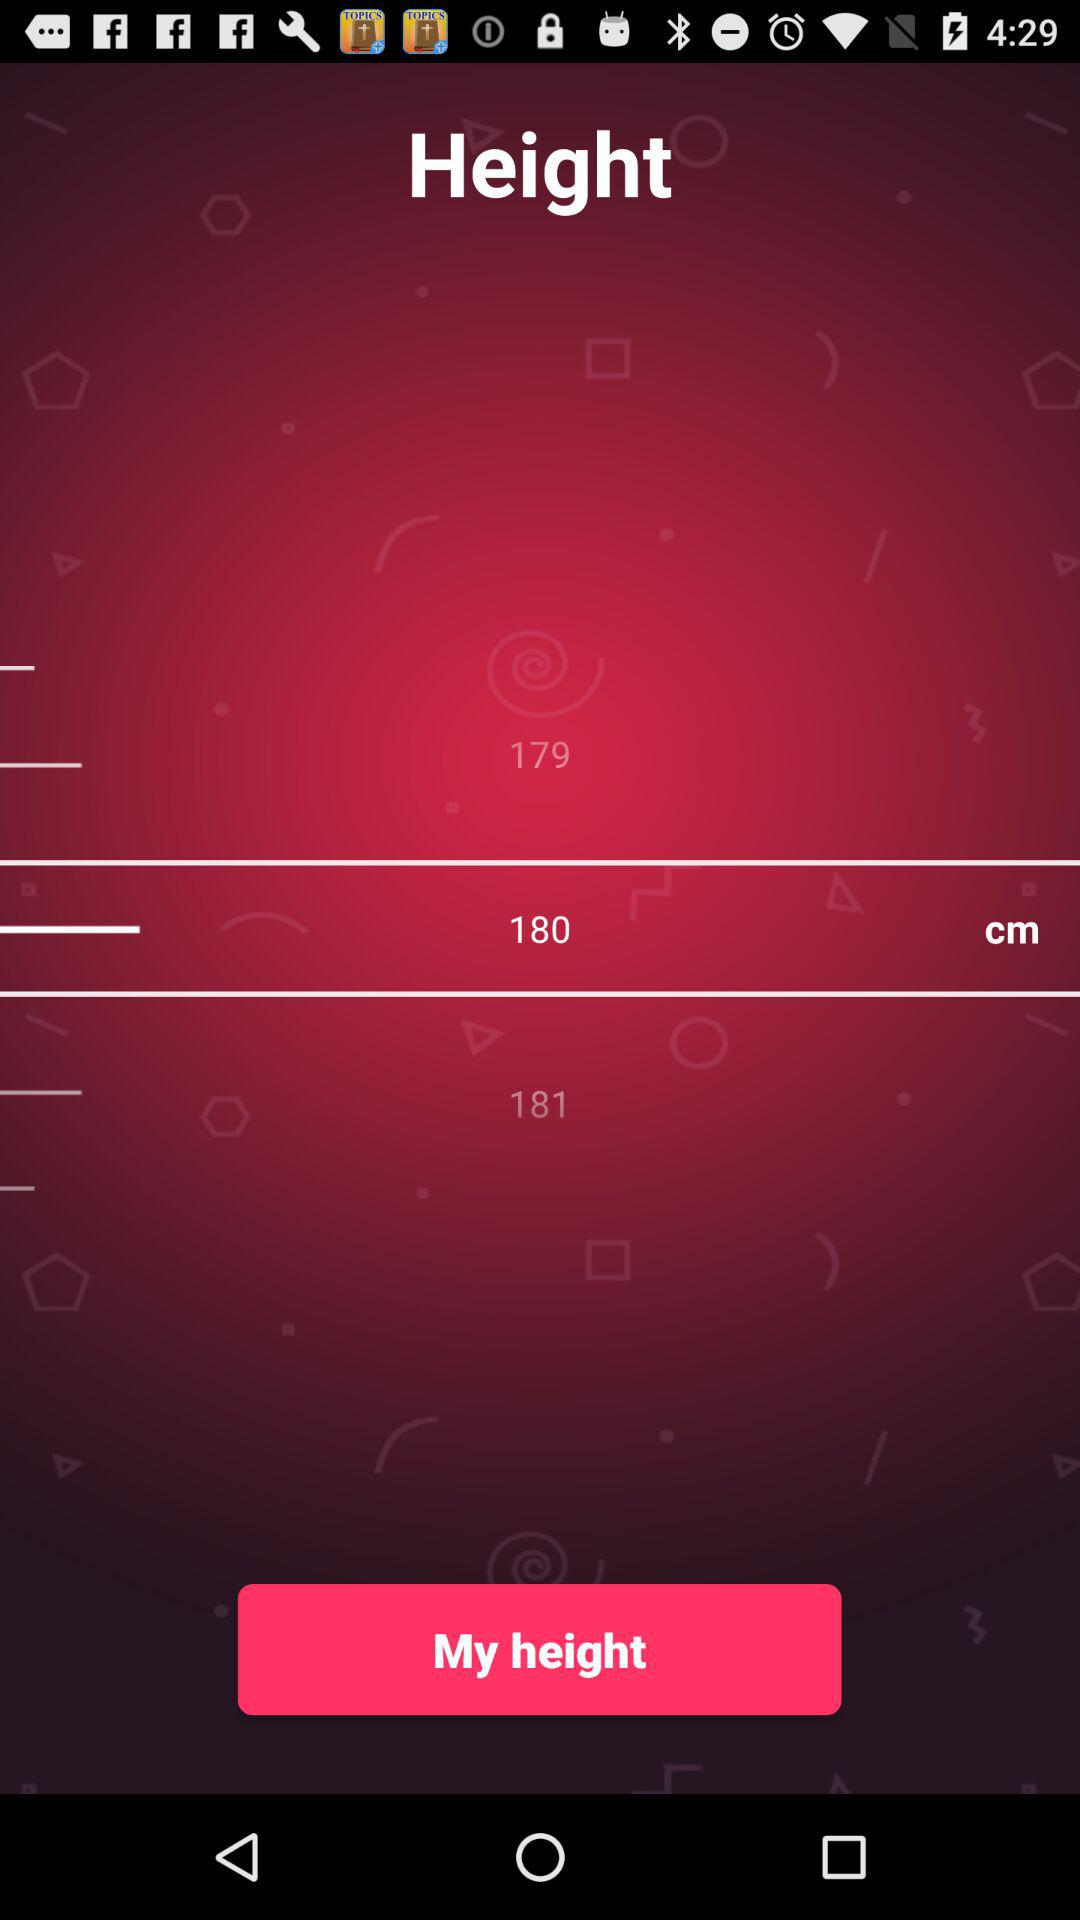What is the unit of height? The unit of height is centimeters. 